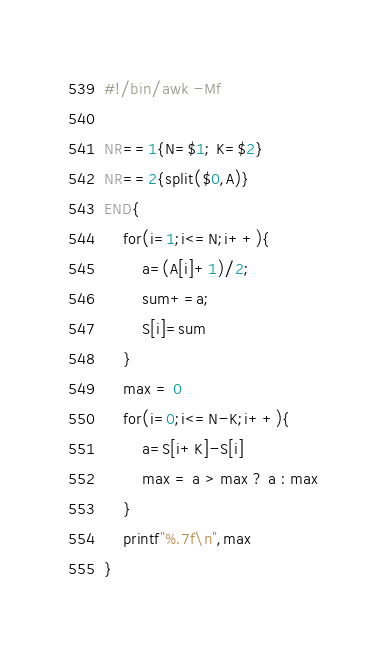<code> <loc_0><loc_0><loc_500><loc_500><_Awk_>#!/bin/awk -Mf

NR==1{N=$1; K=$2}
NR==2{split($0,A)}
END{
    for(i=1;i<=N;i++){
        a=(A[i]+1)/2;
        sum+=a;
        S[i]=sum
    }
    max = 0
    for(i=0;i<=N-K;i++){
        a=S[i+K]-S[i]
        max = a > max ? a : max
    }
    printf"%.7f\n",max
}
</code> 